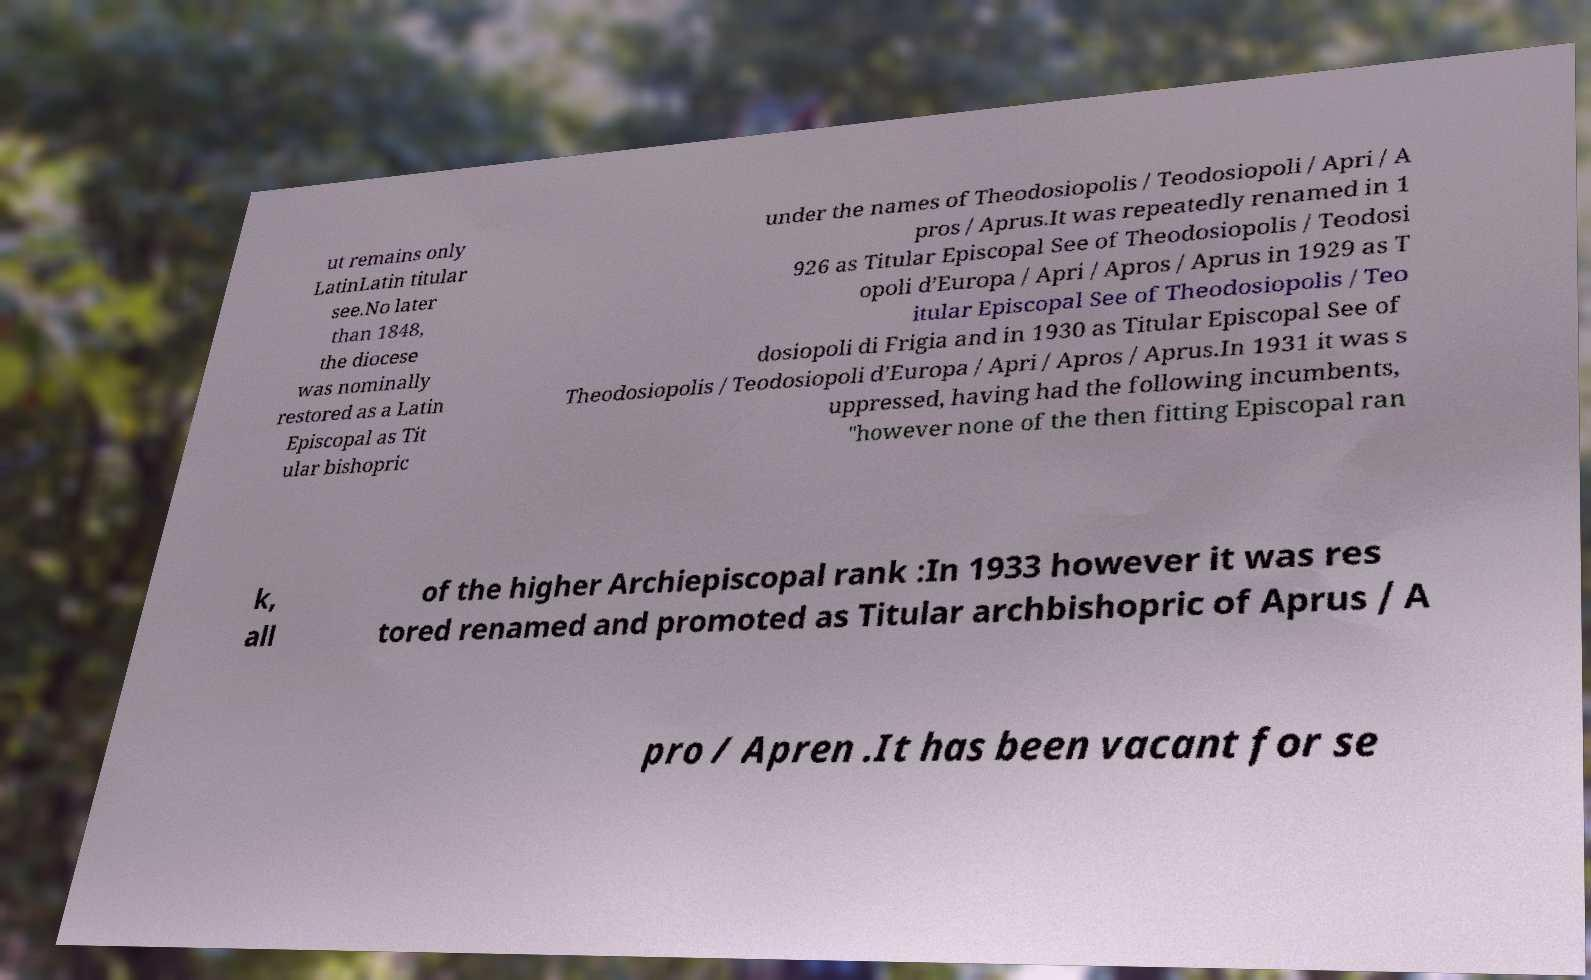Can you accurately transcribe the text from the provided image for me? ut remains only LatinLatin titular see.No later than 1848, the diocese was nominally restored as a Latin Episcopal as Tit ular bishopric under the names of Theodosiopolis / Teodosiopoli / Apri / A pros / Aprus.It was repeatedly renamed in 1 926 as Titular Episcopal See of Theodosiopolis / Teodosi opoli d’Europa / Apri / Apros / Aprus in 1929 as T itular Episcopal See of Theodosiopolis / Teo dosiopoli di Frigia and in 1930 as Titular Episcopal See of Theodosiopolis / Teodosiopoli d’Europa / Apri / Apros / Aprus.In 1931 it was s uppressed, having had the following incumbents, "however none of the then fitting Episcopal ran k, all of the higher Archiepiscopal rank :In 1933 however it was res tored renamed and promoted as Titular archbishopric of Aprus / A pro / Apren .It has been vacant for se 